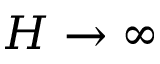<formula> <loc_0><loc_0><loc_500><loc_500>H \to \infty</formula> 